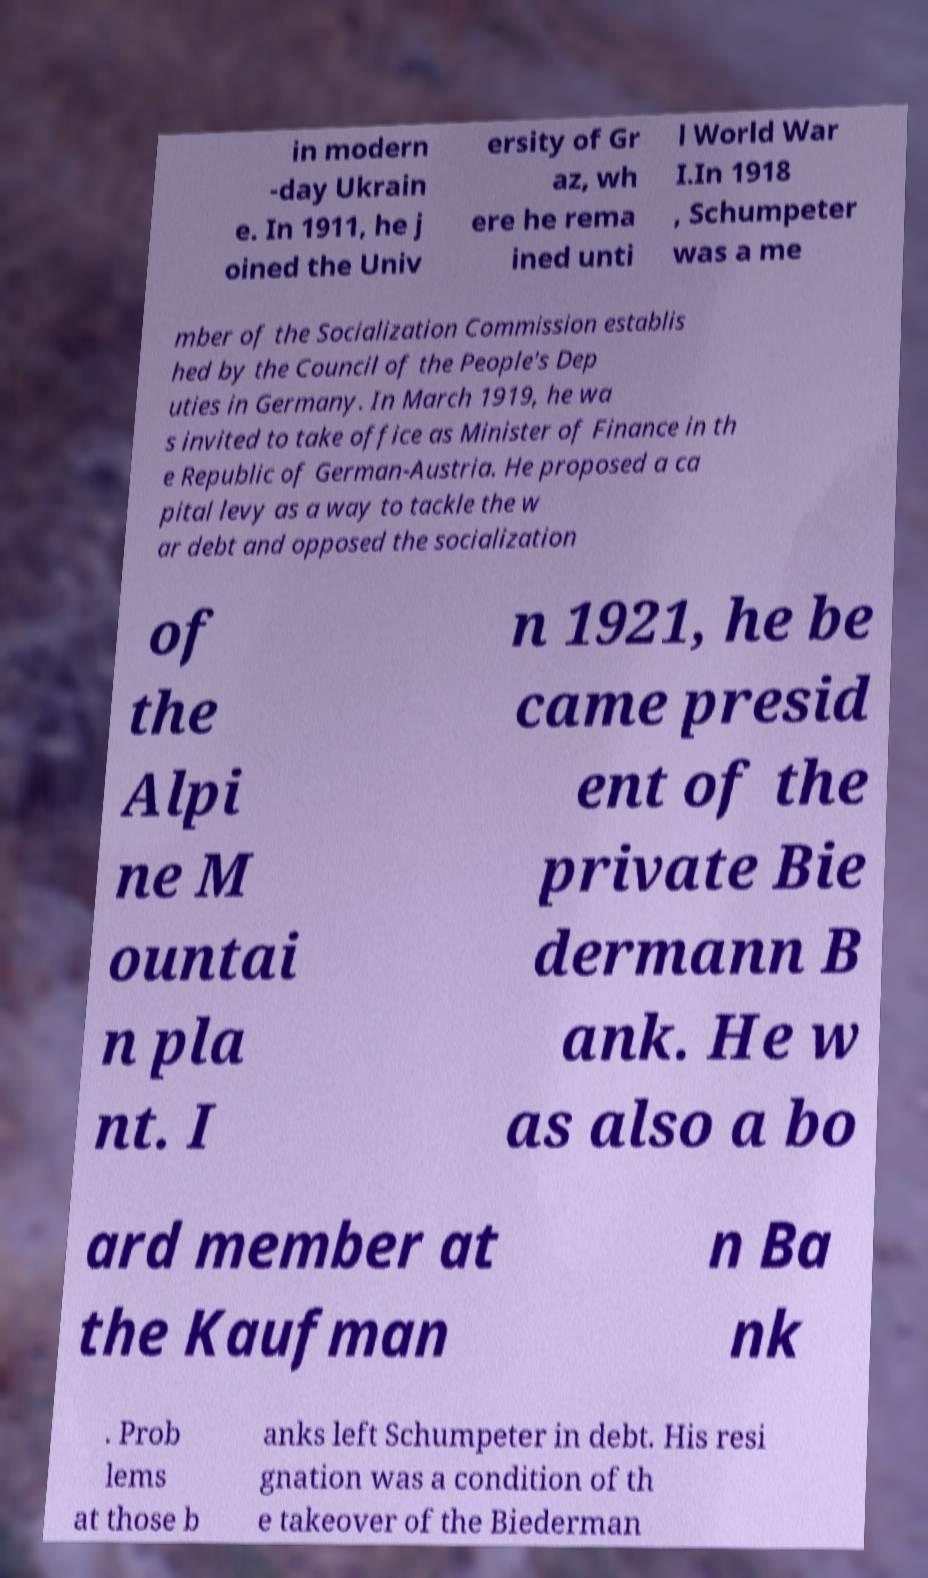Can you accurately transcribe the text from the provided image for me? in modern -day Ukrain e. In 1911, he j oined the Univ ersity of Gr az, wh ere he rema ined unti l World War I.In 1918 , Schumpeter was a me mber of the Socialization Commission establis hed by the Council of the People's Dep uties in Germany. In March 1919, he wa s invited to take office as Minister of Finance in th e Republic of German-Austria. He proposed a ca pital levy as a way to tackle the w ar debt and opposed the socialization of the Alpi ne M ountai n pla nt. I n 1921, he be came presid ent of the private Bie dermann B ank. He w as also a bo ard member at the Kaufman n Ba nk . Prob lems at those b anks left Schumpeter in debt. His resi gnation was a condition of th e takeover of the Biederman 